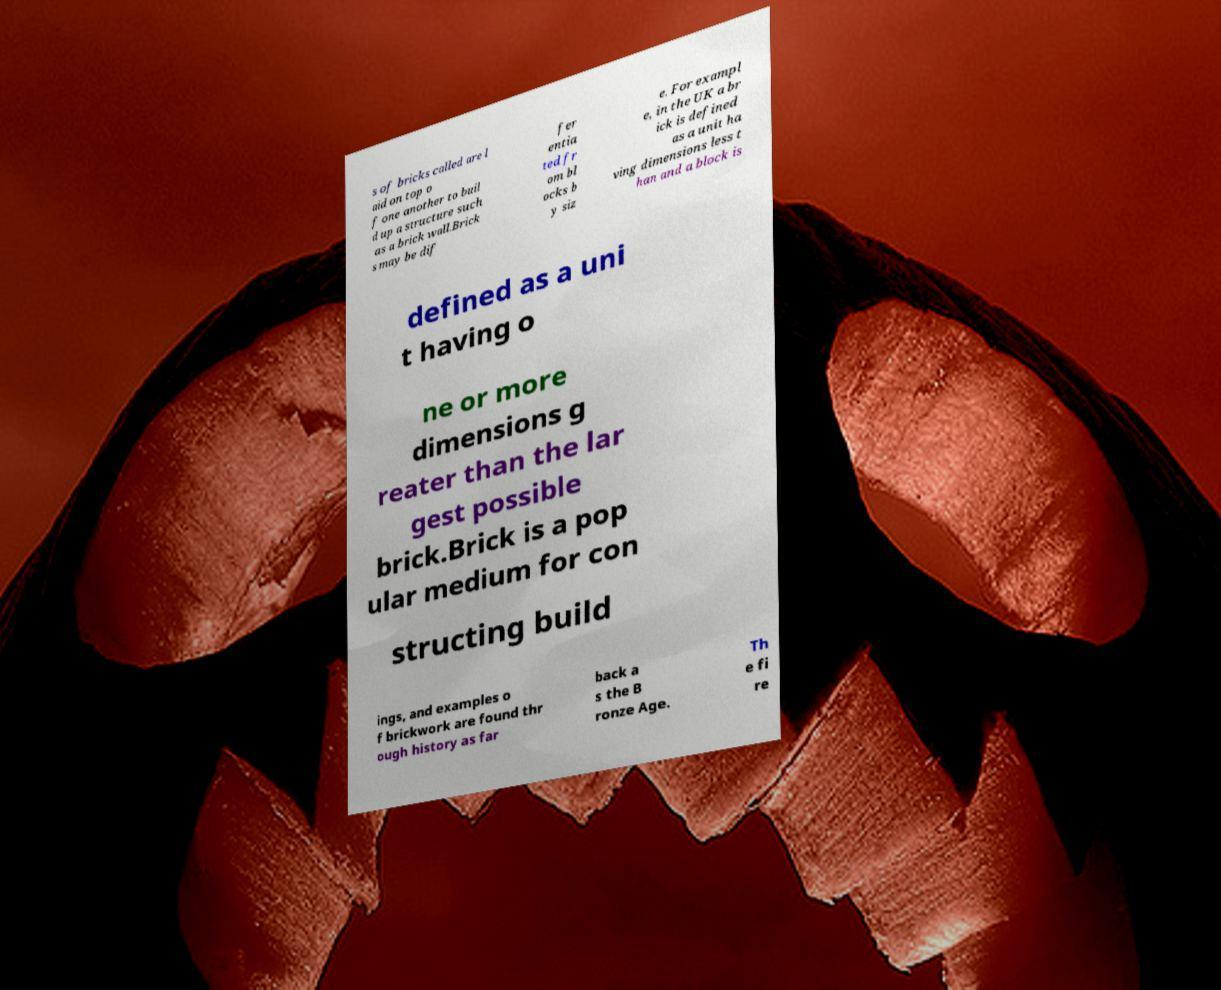What messages or text are displayed in this image? I need them in a readable, typed format. s of bricks called are l aid on top o f one another to buil d up a structure such as a brick wall.Brick s may be dif fer entia ted fr om bl ocks b y siz e. For exampl e, in the UK a br ick is defined as a unit ha ving dimensions less t han and a block is defined as a uni t having o ne or more dimensions g reater than the lar gest possible brick.Brick is a pop ular medium for con structing build ings, and examples o f brickwork are found thr ough history as far back a s the B ronze Age. Th e fi re 